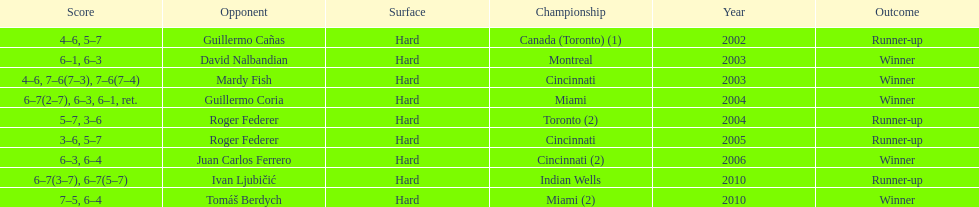Was roddick more frequently a runner-up or a champion? Winner. 